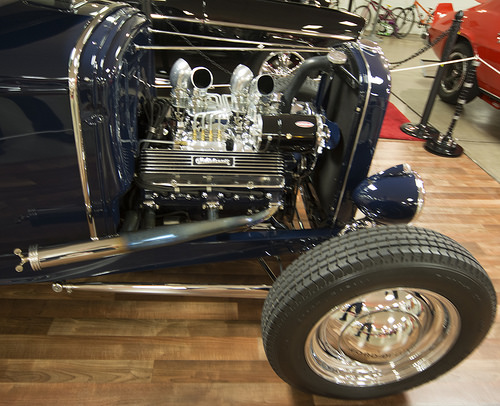<image>
Is there a car on the stage? Yes. Looking at the image, I can see the car is positioned on top of the stage, with the stage providing support. 